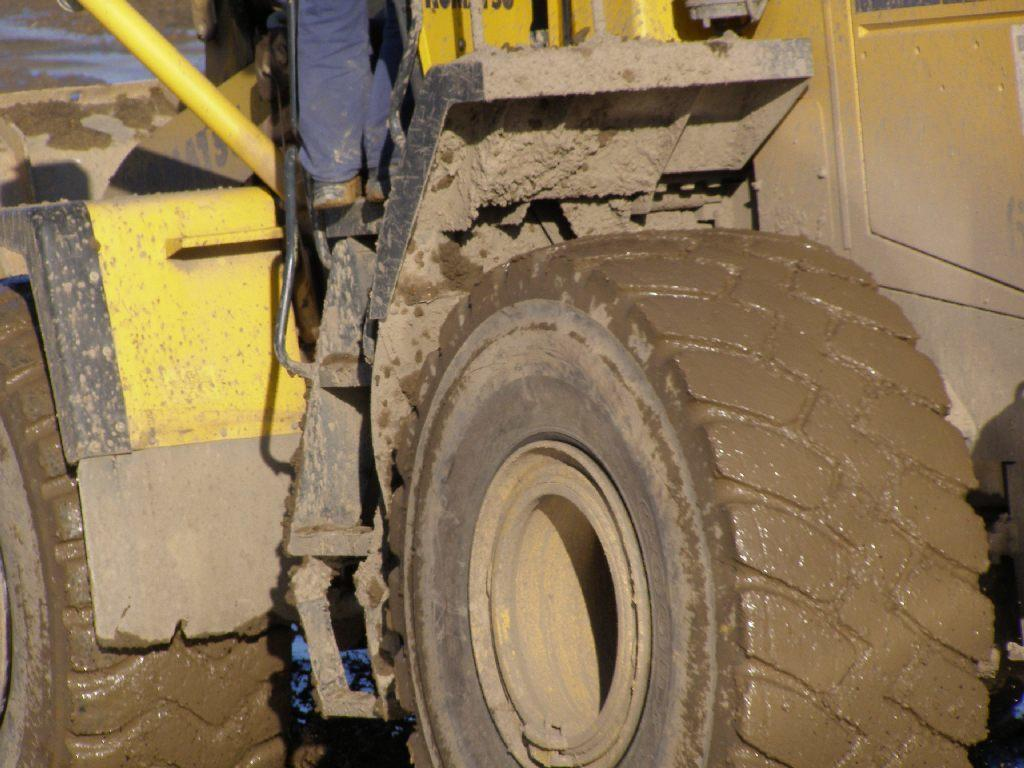What is the main subject of the image? The main subject of the image is a tractor. What color is the tractor? The tractor is yellow in color. Is there anyone operating the tractor? Yes, there is a person on the tractor. What can be seen in the background of the image? There is mud visible in the background of the image. Is there a carriage being pulled by the tractor in the image? No, there is no carriage being pulled by the tractor in the image. The tractor is being operated by a person, and the background features mud. 